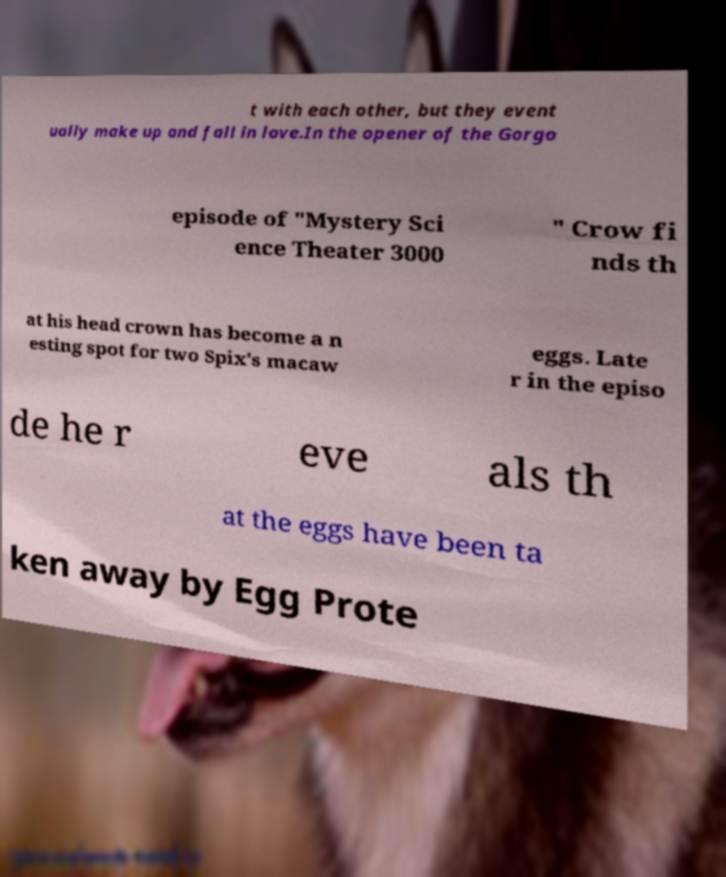Could you extract and type out the text from this image? t with each other, but they event ually make up and fall in love.In the opener of the Gorgo episode of "Mystery Sci ence Theater 3000 " Crow fi nds th at his head crown has become a n esting spot for two Spix's macaw eggs. Late r in the episo de he r eve als th at the eggs have been ta ken away by Egg Prote 